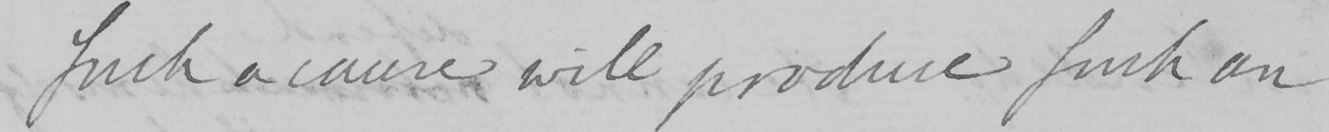Please provide the text content of this handwritten line. such a cause will produce such an 